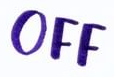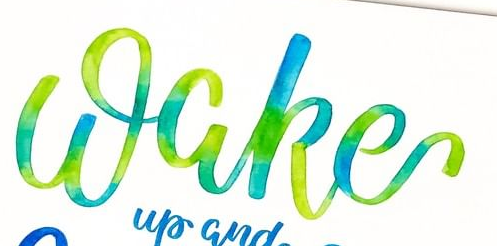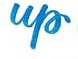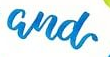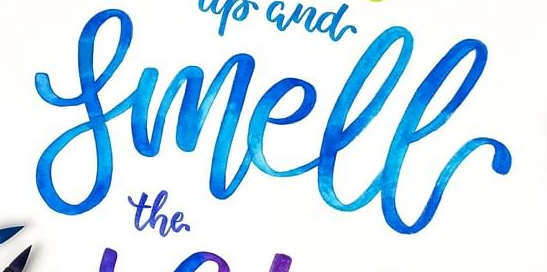Identify the words shown in these images in order, separated by a semicolon. OFF; Wake; up; and; Smell 